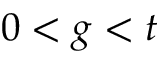<formula> <loc_0><loc_0><loc_500><loc_500>0 < g < t</formula> 